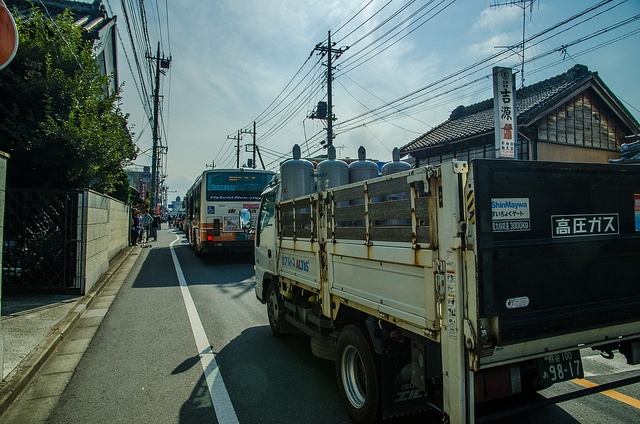Describe the objects in this image and their specific colors. I can see truck in black, gray, and purple tones, bus in black, gray, darkblue, and teal tones, people in black, teal, gray, and darkblue tones, people in black, darkblue, gray, and teal tones, and people in black, teal, and gray tones in this image. 